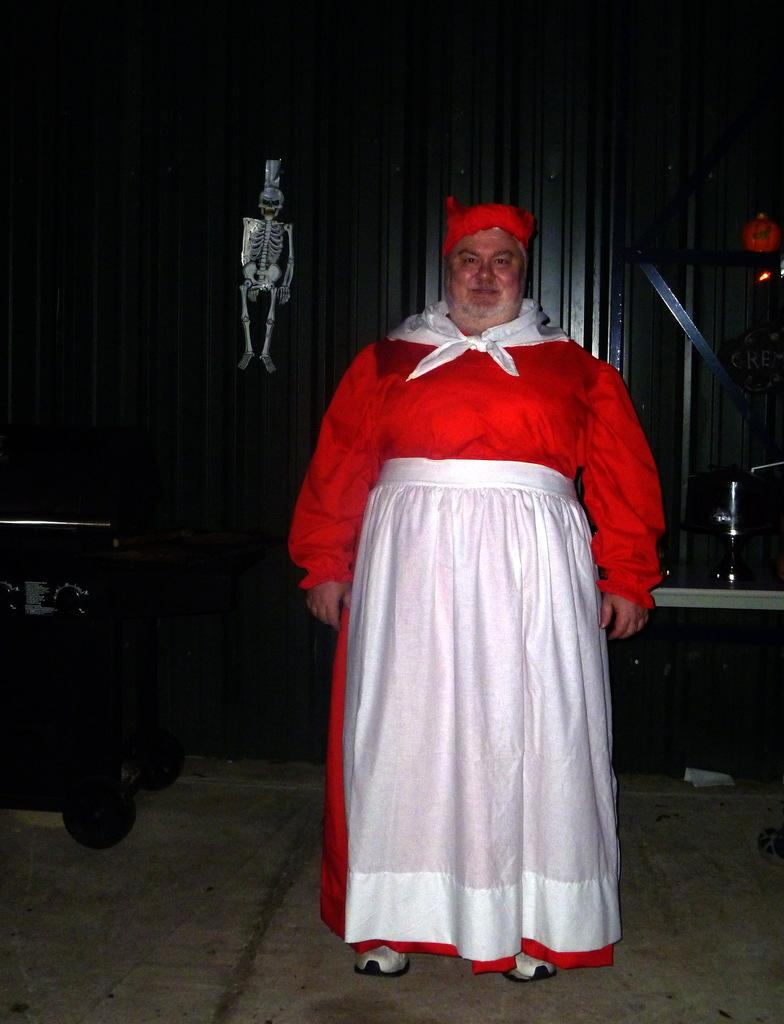Who is present in the image? There is a man in the image. What is the man wearing? The man is wearing a red and white costume. What other object or figure can be seen in the image? There is a skeleton in the image. How is the skeleton positioned in relation to the man? The skeleton is hanged to a surface behind the man. What type of government is represented by the man in the image? There is no indication of any government or political affiliation in the image. --- Facts: 1. There is a car in the image. 2. The car is parked on the street. 3. There are trees on both sides of the street. 4. The sky is visible in the image. Absurd Topics: parrot, dance, ocean Conversation: What is the main subject of the image? The main subject of the image is a car. Where is the car located in the image? The car is parked on the street. What can be seen on both sides of the street? There are trees on both sides of the street. What is visible in the background of the image? The sky is visible in the image. Reasoning: Let's think step by step in order to produce the conversation. We start by identifying the main subject in the image, which is the car. Then, we describe the car's location, focusing on the fact that it is parked on the street. Next, we mention the presence of trees on both sides of the street and the visibility of the sky in the background. Each question is designed to elicit a specific detail about the image that is known from the provided facts. Absurd Question/Answer: Can you see a parrot dancing by the ocean in the image? There is no parrot, dancing, or ocean present in the image. 